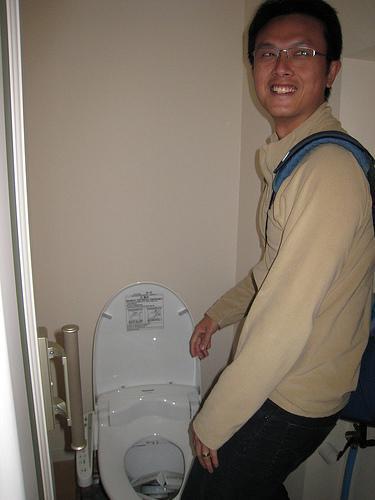How many people are in the picture?
Give a very brief answer. 1. 